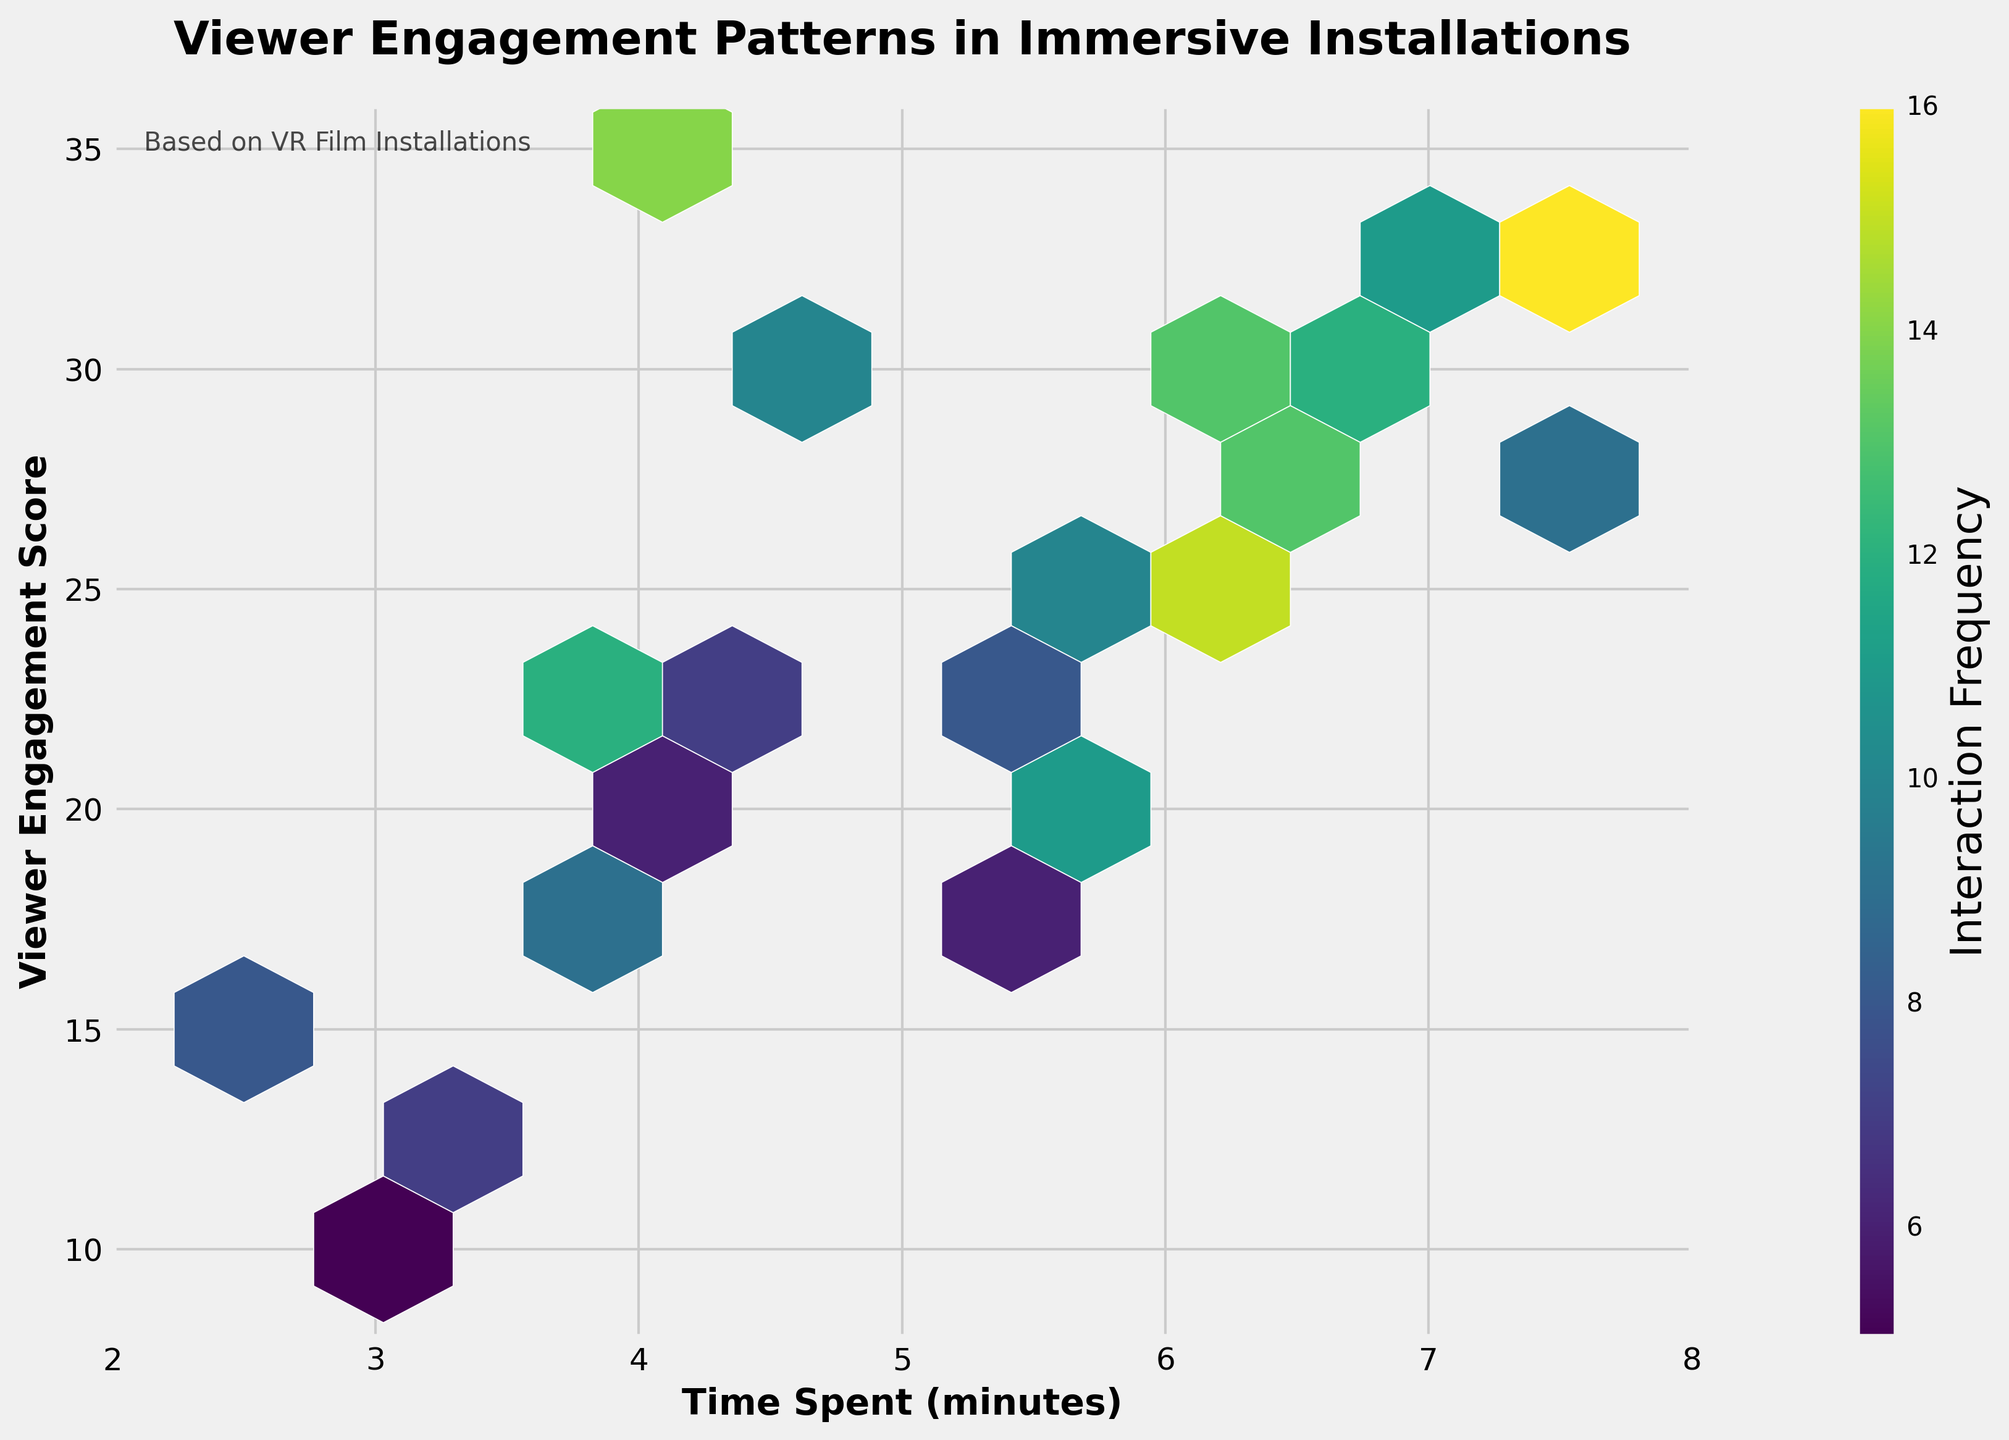What is the title of the figure? The text at the top center of the plot indicates the title. It reads "Viewer Engagement Patterns in Immersive Installations".
Answer: Viewer Engagement Patterns in Immersive Installations What does the color gradient represent in the plot? The color gradient in the hexbin plot typically indicates values, and in this case, the colorbar shows that it represents the "Interaction Frequency" of viewers.
Answer: Interaction Frequency What are the x and y-axis labels? The text next to the x and y-axis displays the labels. "Time Spent (minutes)" is the x-axis label, and "Viewer Engagement Score" is the y-axis label.
Answer: Time Spent (minutes) and Viewer Engagement Score What is the average interaction frequency for the hexbin cells with the highest density? The color in the hexbin cells shows the interaction frequency. The cells with the brightest color represent the highest frequency, specifically around the value provided in the colorbar for the brightest color (approximately 15-16).
Answer: Approximately 15-16 Which region shows the least engagement? The areas with the darkest colors (close to the initial shades on the colorbar) represent the least interaction. Visually, these are located around the bottom region, particularly from time spent 2 to 4 minutes and engagement scores from 10 to 15.
Answer: Time spent 2-4 minutes, engagement score 10-15 How many intervals occupy the time spent (minutes) from 4 to 6? The x-axis ranges from 2 to 8 minutes, divided into intervals. Observing the tick marks and comparison, there are 2 intervals between 4 to 6 minutes.
Answer: 2 intervals Is there a correlation between time spent and interaction frequency? By examining the general trend in the hexbin plot, it shows that as time spent increases, the higher engagement scores and frequencies are observed, suggesting a positive correlation.
Answer: Positive correlation Which region has high interaction frequency but moderate viewer engagement scores? The regions with high interaction frequencies but moderate engagement scores are visible with relatively bright colors, particularly around the cells for time spent 6 to 7 minutes and engagement score range of 25 to 30.
Answer: Time spent 6-7 minutes, engagement score 25-30 Which has the higher interaction frequency: time spent of 7.8 minutes or 7.1 minutes? By observing the hexbin plot colors at these specific points, time spent of 7.8 minutes correlates with a higher interaction frequency (brighter color) compared to 7.1 minutes.
Answer: Time spent of 7.8 minutes 